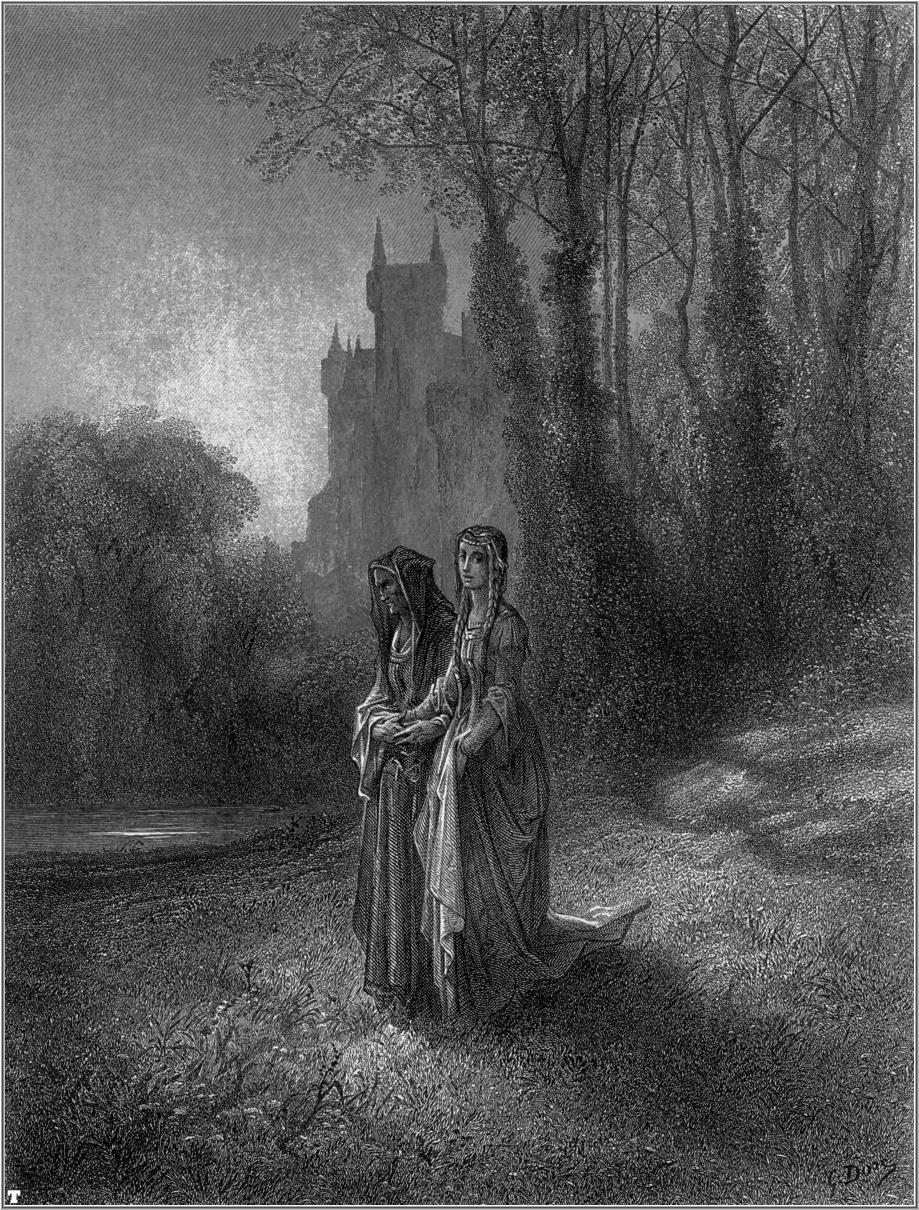What modern-day activities do you think the women would partake in if this scene were set in contemporary times? If the scene were set in contemporary times, the two women might be enjoying a leisurely nature hike, clad in comfortable outdoor wear instead of medieval dresses. One of them might be carrying a basket filled with a picnic for them to enjoy by the water's edge. They could be engaged in taking photographs of the beautiful foliage and the castle ruins with their smartphones, capturing memories to share on social media. Alternatively, they might be participating in a community event like a charity walk or a nature-conservation activity, reflecting a modern sense of camaraderie and shared purpose. Their conversation could revolve around their careers, personal aspirations, or recent travels, blending the timeless tranquility of the forest with the dynamic pace of modern life. 